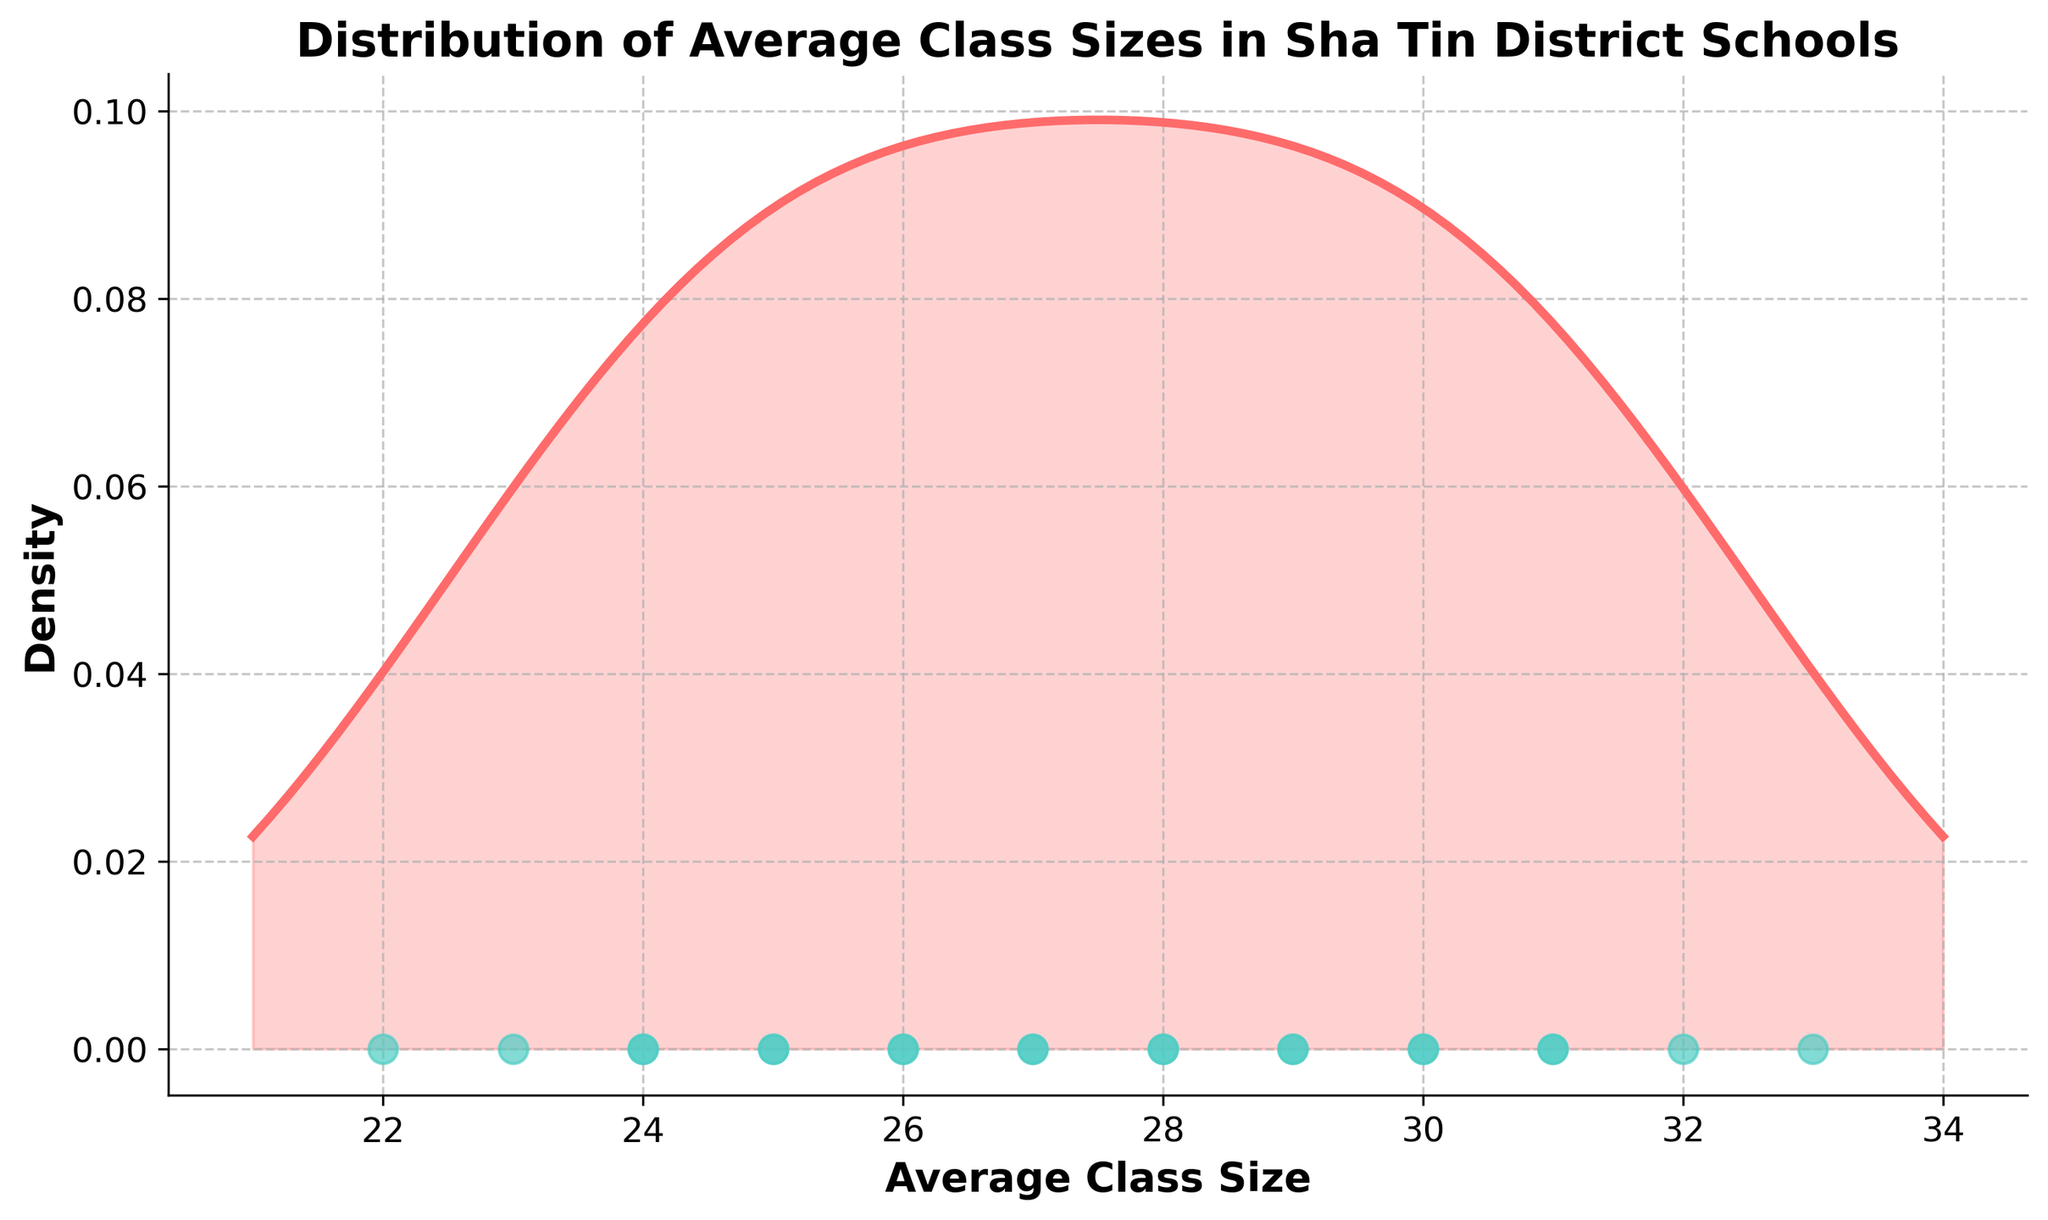What is the title of the plot? The title is located at the top of the plot and clearly states the main information.
Answer: Distribution of Average Class Sizes in Sha Tin District Schools How many schools have average class sizes represented in the plot? By counting the number of data points (dots) along the x-axis, we can determine the number of schools included in the plot.
Answer: 20 Which school has the largest average class size? The data point furthest to the right on the x-axis will correspond to the school with the largest average class size. The value at this point should be compared with the school names.
Answer: Jockey Club Ti-I College Is there a school with an average class size of 24? By observing the x-axis and the aligned data points, we can confirm the presence of a school at the value 24.
Answer: Yes What is the approximate center (mean) of the density curve? The mean can be estimated by identifying the peak (mode) of the density curve. The peak typically indicates where the most common values cluster.
Answer: Around 28 How many schools have an average class size between 29 and 32? By inspecting the scatter plot and counting the number of data points between x-axis values 29 and 32, we can determine this count.
Answer: 6 Which singular school falls below the average class size of 24? By identifying the data point on the scatter plot that is to the left of x-axis value 24, we can determine the school.
Answer: Po Leung Kuk Choi Kai Yau School What range of average class sizes is covered by the density plot? Identifying the minimum and maximum x-axis values gives the range of average class sizes. These endpoints show the spectrum of data covered by the density plot.
Answer: 22 to 33 Is the density curve symmetric, skewed left, or skewed right? Observing the shape of the density curve in relation to its peak will indicate its symmetry or skewness.
Answer: Slightly skewed right What does the area under the density curve represent? Understanding density plots, the area under the curve represents the entire distribution of class sizes and sums up to 1, indicating relative frequency.
Answer: The distribution of all average class sizes 